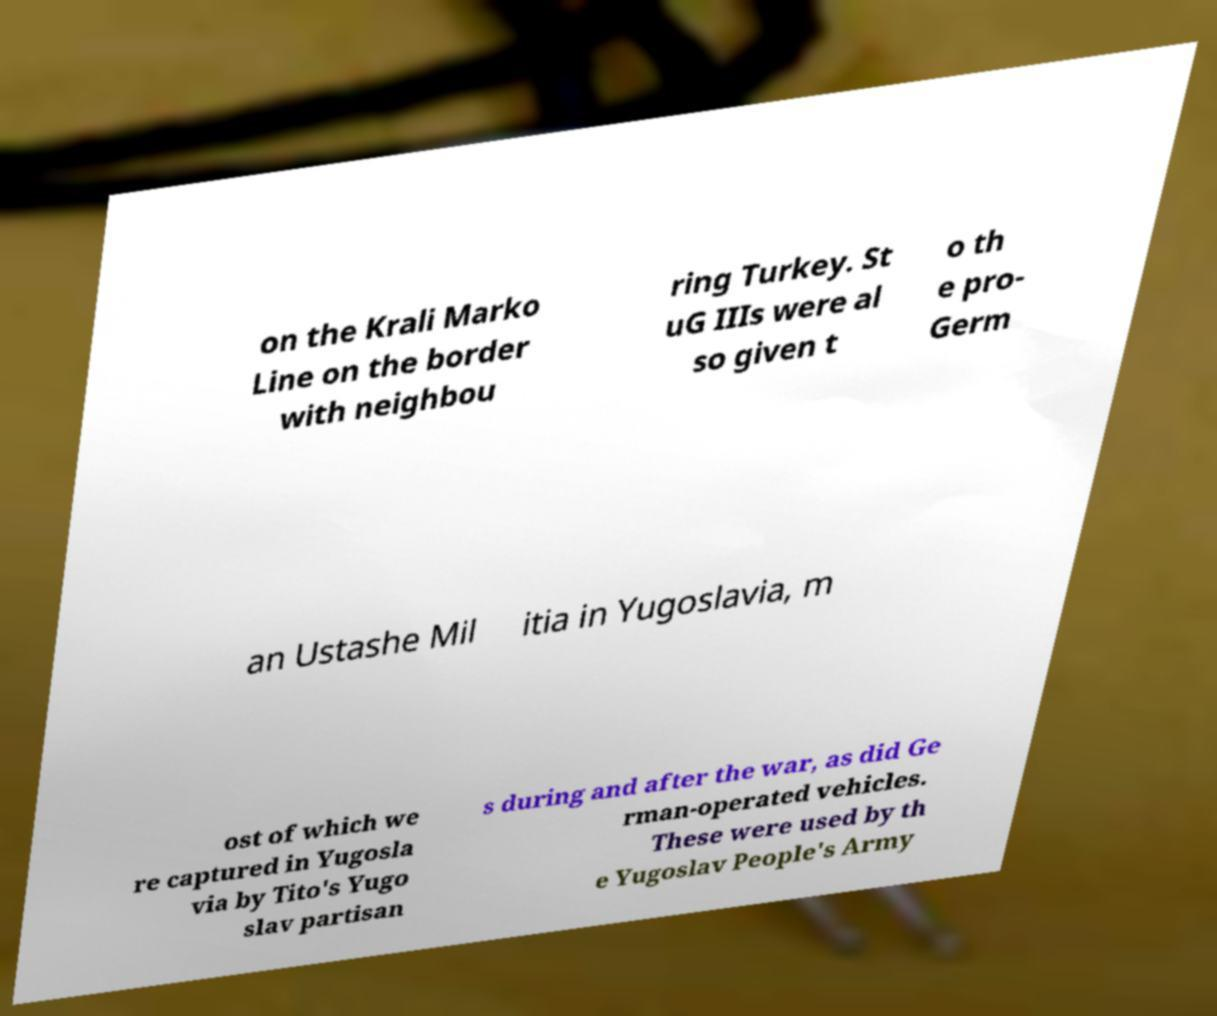There's text embedded in this image that I need extracted. Can you transcribe it verbatim? on the Krali Marko Line on the border with neighbou ring Turkey. St uG IIIs were al so given t o th e pro- Germ an Ustashe Mil itia in Yugoslavia, m ost of which we re captured in Yugosla via by Tito's Yugo slav partisan s during and after the war, as did Ge rman-operated vehicles. These were used by th e Yugoslav People's Army 